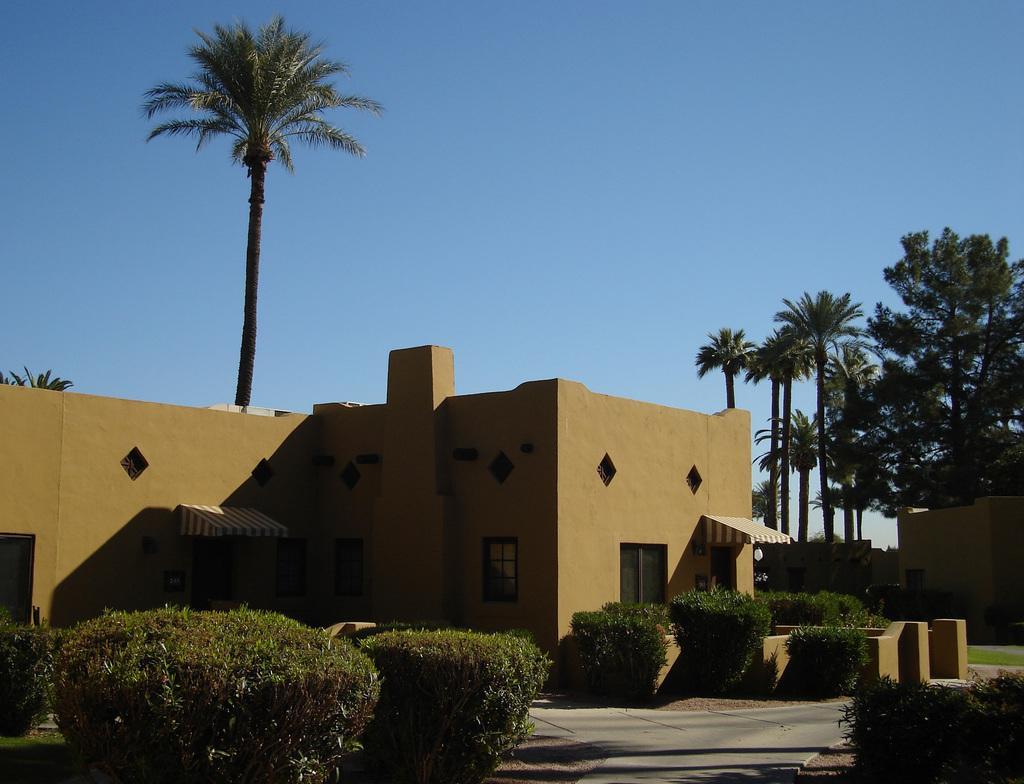Could you give a brief overview of what you see in this image? In the image I can see a house and around there are some plants and trees. 